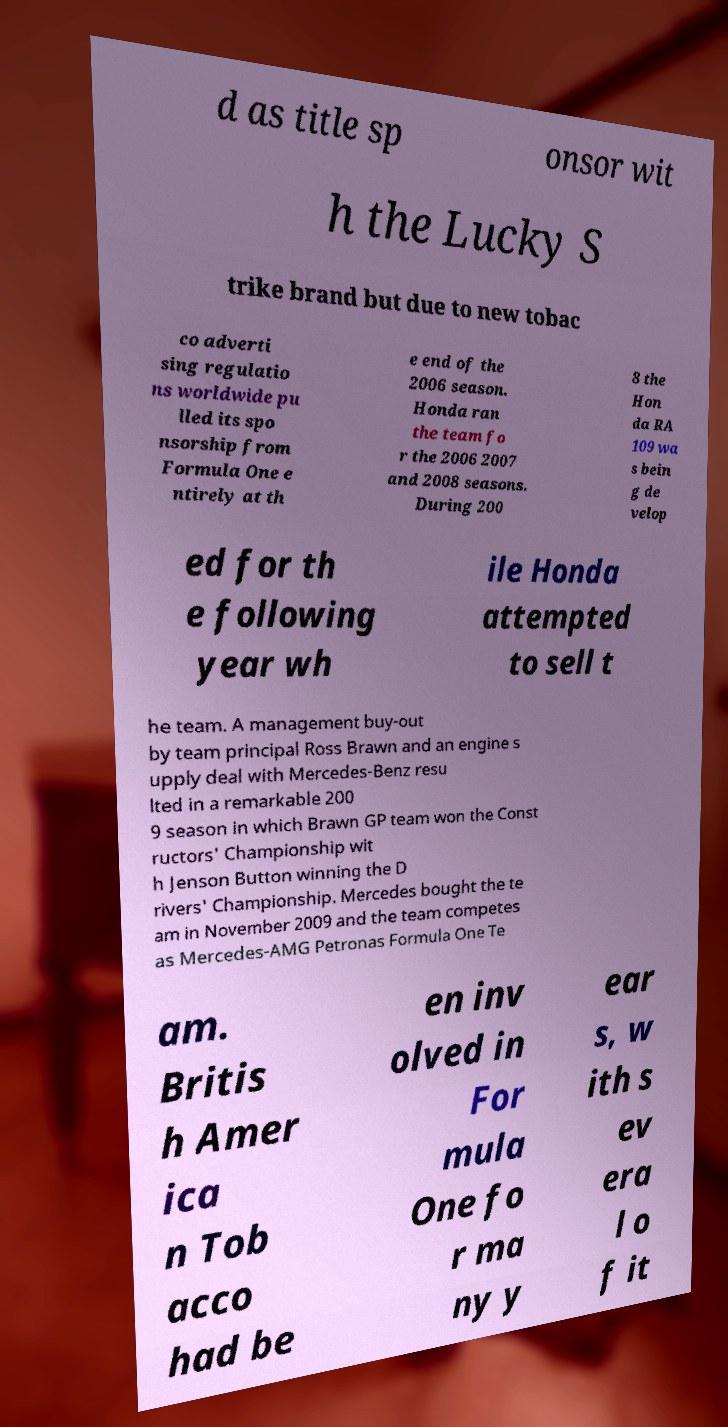I need the written content from this picture converted into text. Can you do that? d as title sp onsor wit h the Lucky S trike brand but due to new tobac co adverti sing regulatio ns worldwide pu lled its spo nsorship from Formula One e ntirely at th e end of the 2006 season. Honda ran the team fo r the 2006 2007 and 2008 seasons. During 200 8 the Hon da RA 109 wa s bein g de velop ed for th e following year wh ile Honda attempted to sell t he team. A management buy-out by team principal Ross Brawn and an engine s upply deal with Mercedes-Benz resu lted in a remarkable 200 9 season in which Brawn GP team won the Const ructors' Championship wit h Jenson Button winning the D rivers' Championship. Mercedes bought the te am in November 2009 and the team competes as Mercedes-AMG Petronas Formula One Te am. Britis h Amer ica n Tob acco had be en inv olved in For mula One fo r ma ny y ear s, w ith s ev era l o f it 